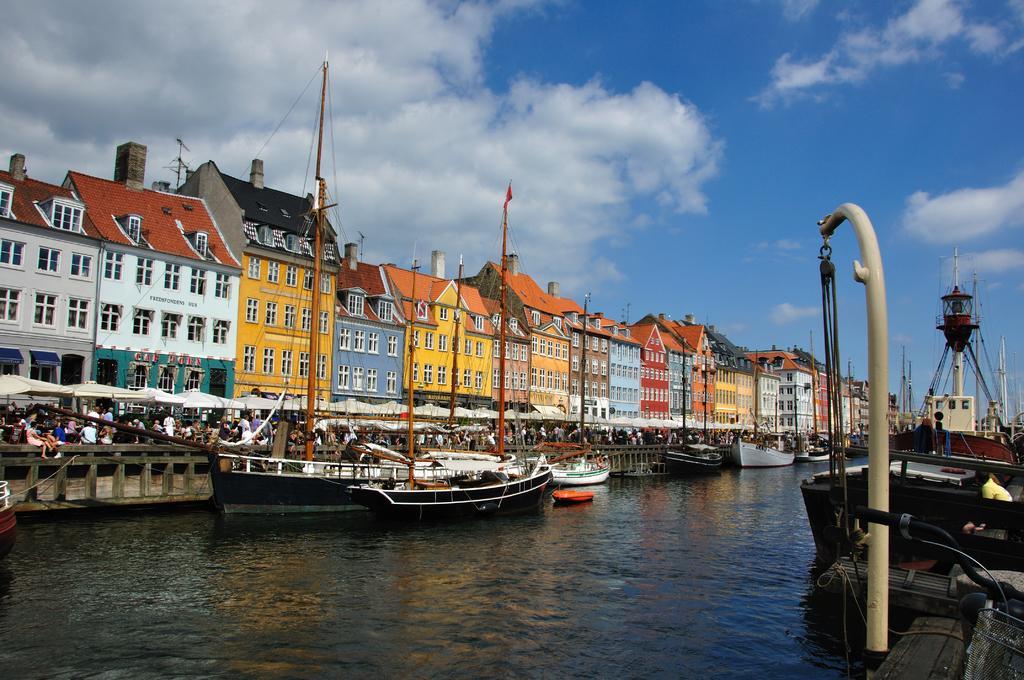Can you describe this image briefly? In this picture I can see there is a river and there are few boats sailing on the water. In the backdrop there are huge number of people standing and there are many colorful buildings. 